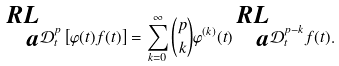Convert formula to latex. <formula><loc_0><loc_0><loc_500><loc_500>\prescript { R L } { a } { \mathcal { D } } _ { t } ^ { p } \left [ \varphi ( t ) f ( t ) \right ] = \sum _ { k = 0 } ^ { \infty } { p \choose k } \varphi ^ { ( k ) } ( t ) \prescript { R L } { a } { \mathcal { D } } _ { t } ^ { p - k } f ( t ) .</formula> 